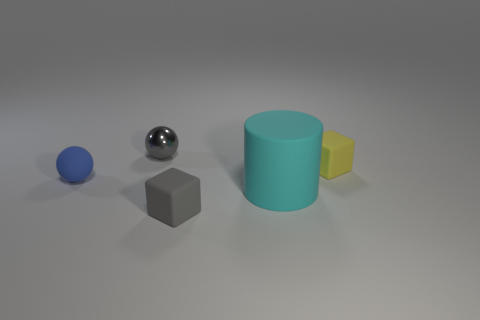Add 2 large purple rubber spheres. How many objects exist? 7 Subtract all cylinders. How many objects are left? 4 Subtract 0 purple cylinders. How many objects are left? 5 Subtract all tiny green rubber things. Subtract all rubber cubes. How many objects are left? 3 Add 3 tiny gray metal spheres. How many tiny gray metal spheres are left? 4 Add 4 tiny green objects. How many tiny green objects exist? 4 